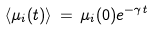Convert formula to latex. <formula><loc_0><loc_0><loc_500><loc_500>\langle \mu _ { i } ( t ) \rangle \, = \, \mu _ { i } ( 0 ) e ^ { - \gamma t }</formula> 